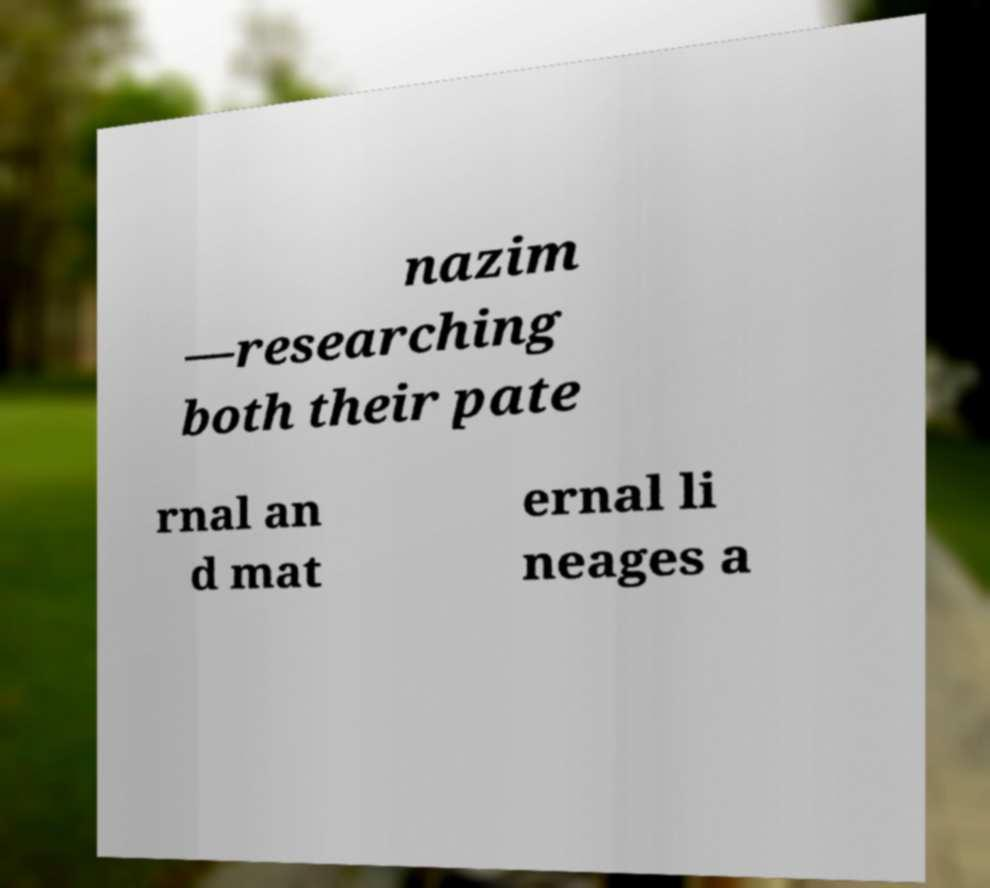Could you extract and type out the text from this image? nazim —researching both their pate rnal an d mat ernal li neages a 